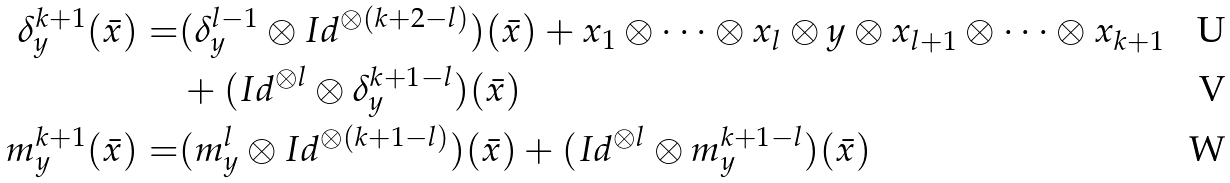Convert formula to latex. <formula><loc_0><loc_0><loc_500><loc_500>\delta _ { y } ^ { k + 1 } ( \bar { x } ) = & ( \delta _ { y } ^ { l - 1 } \otimes I d ^ { \otimes ( k + 2 - l ) } ) ( \bar { x } ) + x _ { 1 } \otimes \dots \otimes x _ { l } \otimes y \otimes x _ { l + 1 } \otimes \dots \otimes x _ { k + 1 } \\ & + ( I d ^ { \otimes l } \otimes \delta _ { y } ^ { k + 1 - l } ) ( \bar { x } ) \\ m _ { y } ^ { k + 1 } ( \bar { x } ) = & ( m _ { y } ^ { l } \otimes I d ^ { \otimes ( k + 1 - l ) } ) ( \bar { x } ) + ( I d ^ { \otimes l } \otimes m _ { y } ^ { k + 1 - l } ) ( \bar { x } )</formula> 